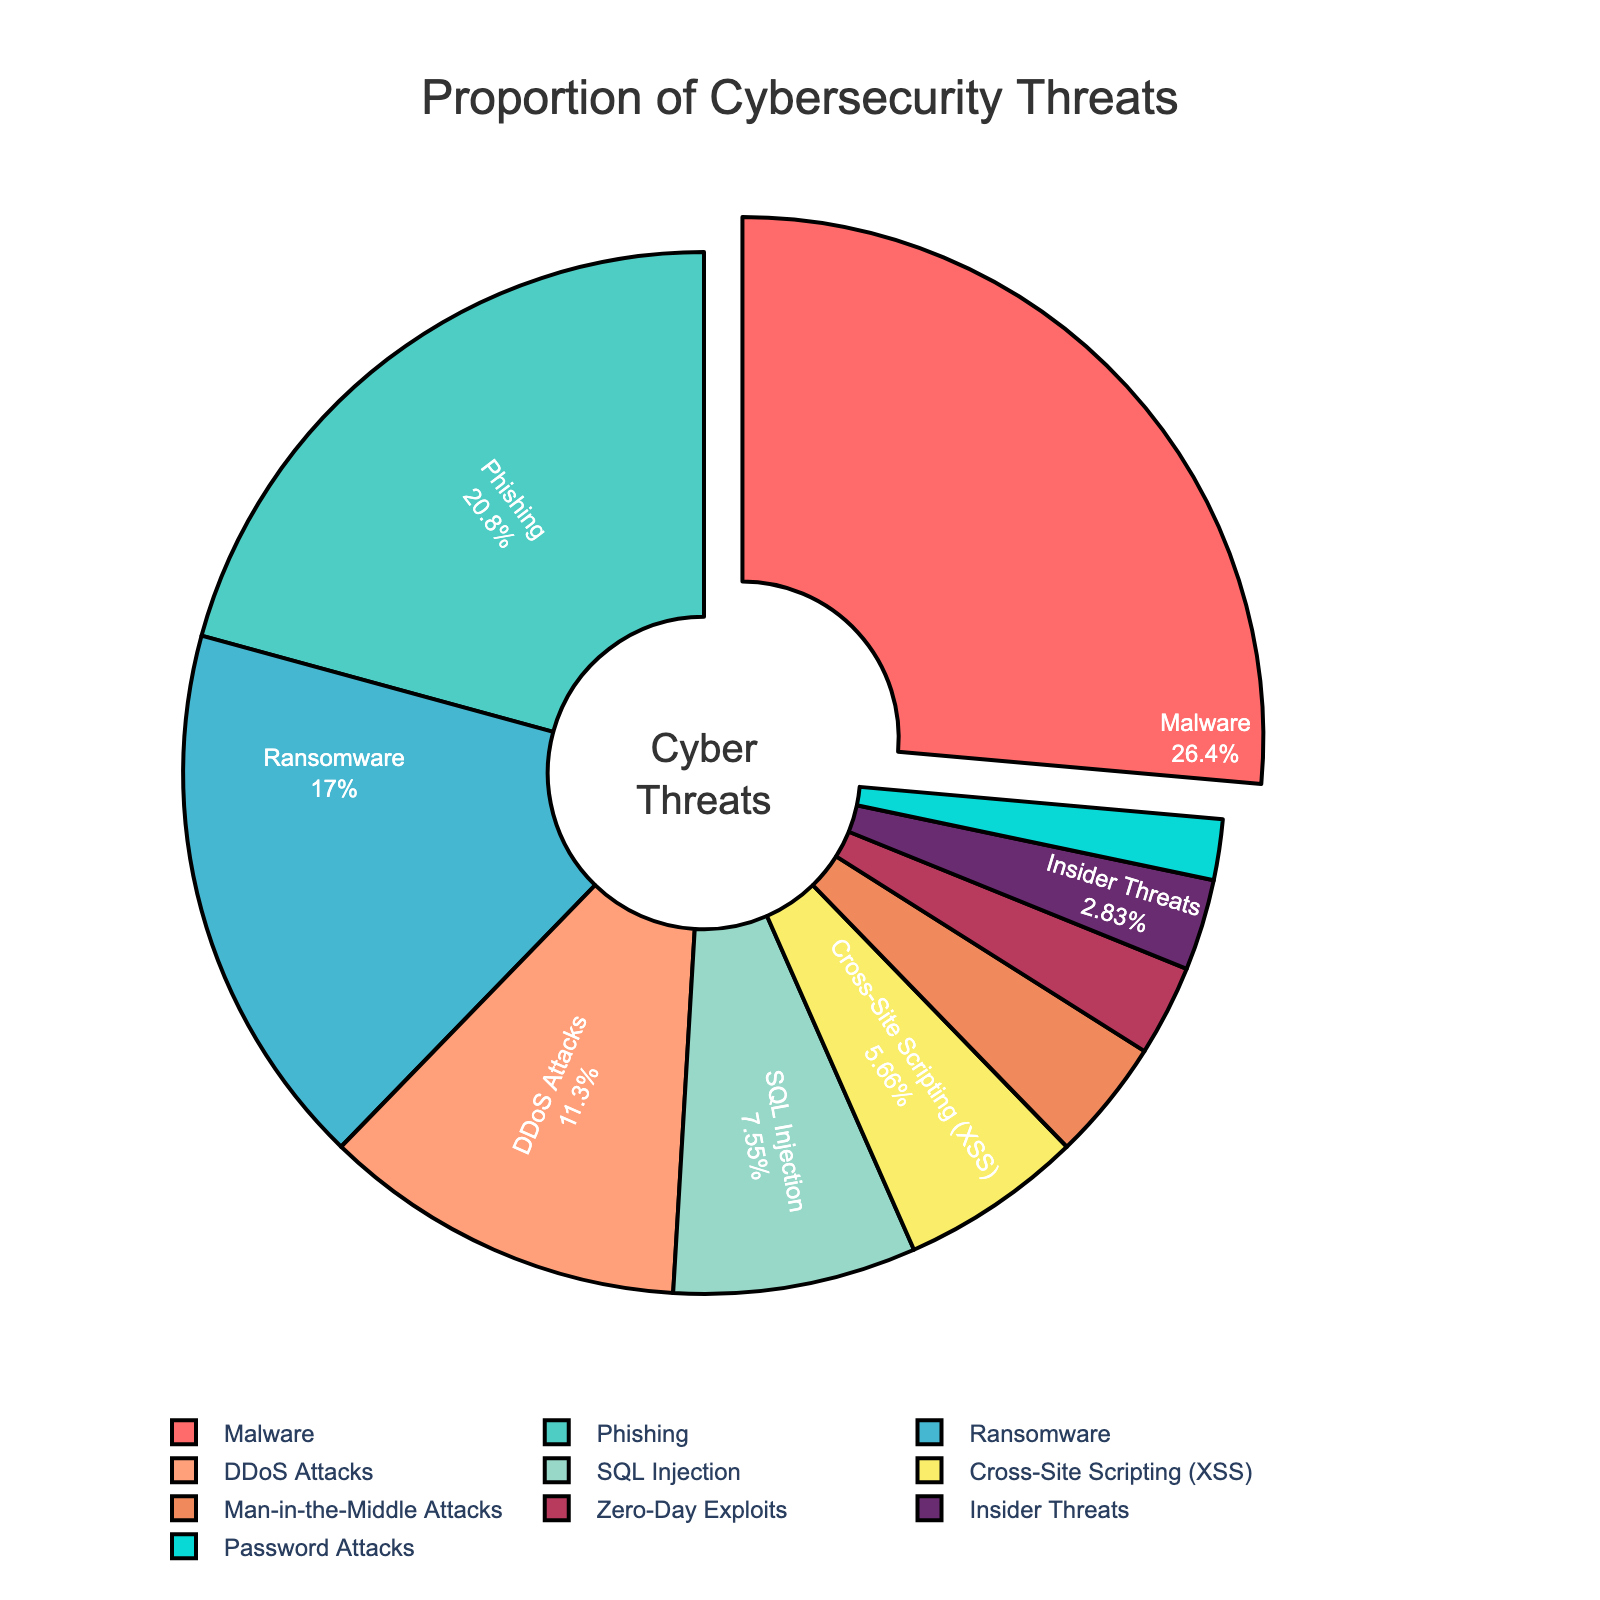What is the most common type of cybersecurity threat faced by organizations? The pie chart shows the proportion of different cybersecurity threats, with Malware having the largest section. It is visually pulled out from the chart, highlighting its significance.
Answer: Malware What percentage of threats are accounted for by Ransomware and Phishing combined? From the chart, Ransomware accounts for 18% and Phishing accounts for 22%. Adding these percentages gives 18% + 22% = 40%.
Answer: 40% Which type of attack is the least common according to the pie chart? The smallest section of the pie chart corresponds to Password Attacks, which is 2%.
Answer: Password Attacks Are DDoS Attacks more common than SQL Injection? The chart shows that DDoS Attacks account for 12% while SQL Injection accounts for 8%. Since 12% is greater than 8%, DDoS Attacks are more common.
Answer: Yes What is the combined percentage of less common threats (<5%)? Reviewing the chart, Man-in-the-Middle Attacks (4%), Zero-Day Exploits (3%), Insider Threats (3%), and Password Attacks (2%) all have less than 5%. Summing these, we get 4% + 3% + 3% + 2% = 12%.
Answer: 12% What color represents Ransomware in the pie chart? The pie chart uses a custom color palette. Ransomware is represented by the color blue.
Answer: Blue How much more common are Malware attacks compared to Phishing attacks in terms of percentage points? The chart indicates that Malware accounts for 28%, and Phishing accounts for 22%. The difference is 28% - 22% = 6 percentage points.
Answer: 6 percentage points What proportion of attacks are due to Cross-Site Scripting (XSS) and SQL Injection combined? From the chart, Cross-Site Scripting (XSS) is 6% and SQL Injection is 8%. Adding these percentages gives 6% + 8% = 14%.
Answer: 14% Arrange the top four most common threats in descending order. By inspecting the pie chart, the top four threats in descending order of their percentages are Malware (28%), Phishing (22%), Ransomware (18%), and DDoS Attacks (12%).
Answer: Malware, Phishing, Ransomware, DDoS Attacks 